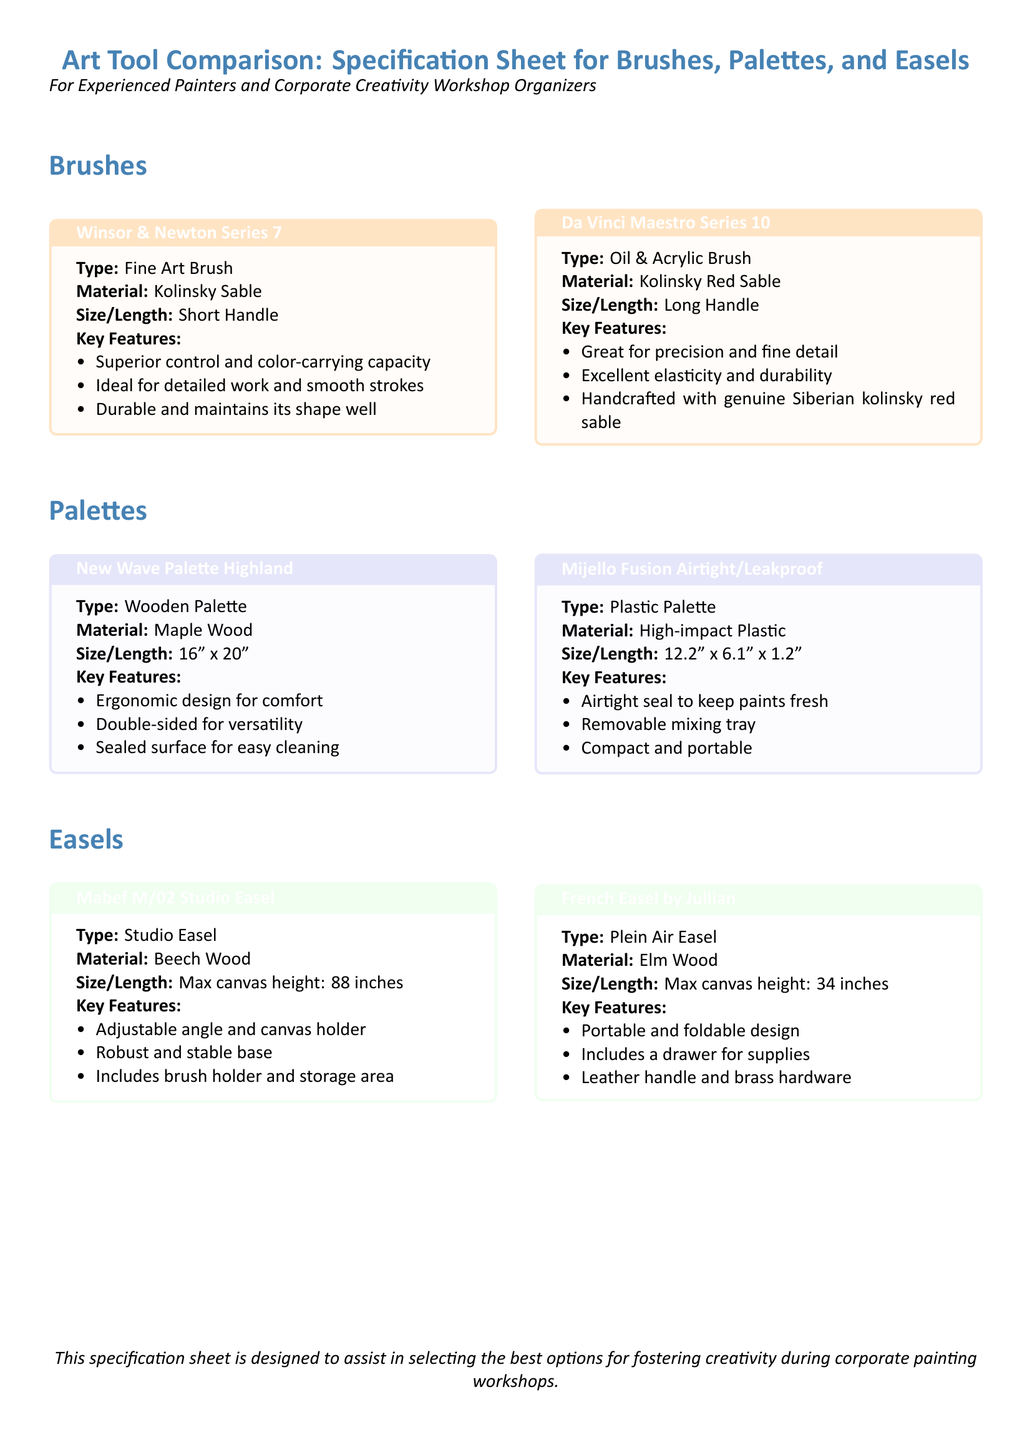What is the brand of the fine art brush? The brand associated with the fine art brush is Winsor & Newton, which is specified in the document.
Answer: Winsor & Newton What is the material of the Mijello Fusion Airtight/Leakproof palette? The document states that the Mijello Fusion palette is made from high-impact plastic.
Answer: High-impact Plastic What is the maximum canvas height for the Mabef M/02 Studio Easel? According to the document, the maximum canvas height for this easel is 88 inches.
Answer: 88 inches Which brush is ideal for detailed work and smooth strokes? The document indicates that the Winsor & Newton Series 7 brush is ideal for detailed work and smooth strokes.
Answer: Winsor & Newton Series 7 How long is the New Wave Palette Highland? The length of the New Wave Palette Highland is specified as 16 inches.
Answer: 16 inches Which easel includes a drawer for supplies? The document notes that the French Easel by Jullian includes a drawer for supplies.
Answer: French Easel by Jullian What type of brush is the Da Vinci Maestro Series 10? The type of brush for the Da Vinci Maestro Series 10 is categorized as an oil and acrylic brush in the document.
Answer: Oil & Acrylic Brush How many key features are listed for the Mabef M/02 Studio Easel? The document lists three key features for the Mabef M/02 Studio Easel.
Answer: Three What type of palette is the New Wave Palette Highland? The document describes the New Wave Palette Highland as a wooden palette.
Answer: Wooden Palette What color is the box for the palettes? The color specified for the palette boxes in the document is ghost white.
Answer: Ghost white 